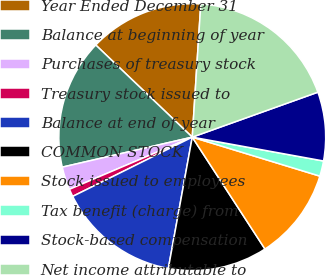<chart> <loc_0><loc_0><loc_500><loc_500><pie_chart><fcel>Year Ended December 31<fcel>Balance at beginning of year<fcel>Purchases of treasury stock<fcel>Treasury stock issued to<fcel>Balance at end of year<fcel>COMMON STOCK<fcel>Stock issued to employees<fcel>Tax benefit (charge) from<fcel>Stock-based compensation<fcel>Net income attributable to<nl><fcel>13.89%<fcel>15.74%<fcel>2.78%<fcel>0.93%<fcel>14.81%<fcel>12.04%<fcel>11.11%<fcel>1.86%<fcel>8.33%<fcel>18.51%<nl></chart> 